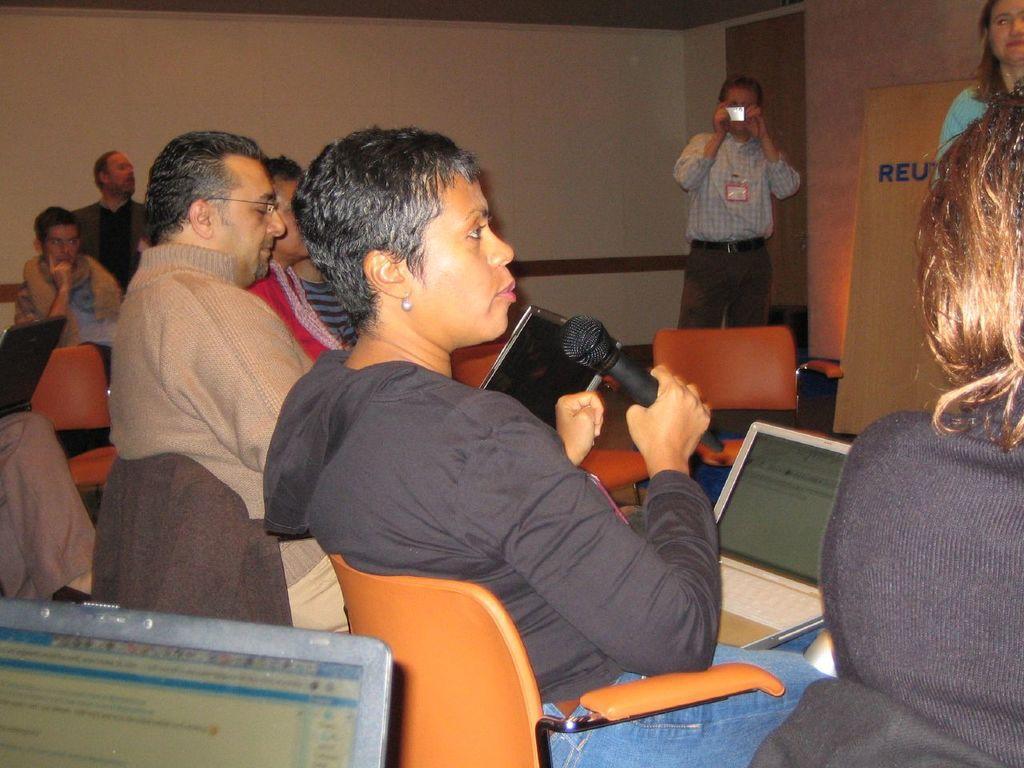How would you summarize this image in a sentence or two? This is an image inside the room. In the foreground we can see a woman holding a mic and speaking. She has a laptop on her thighs. This man in the background is holding a camera in his hands and clicking the pictures. 